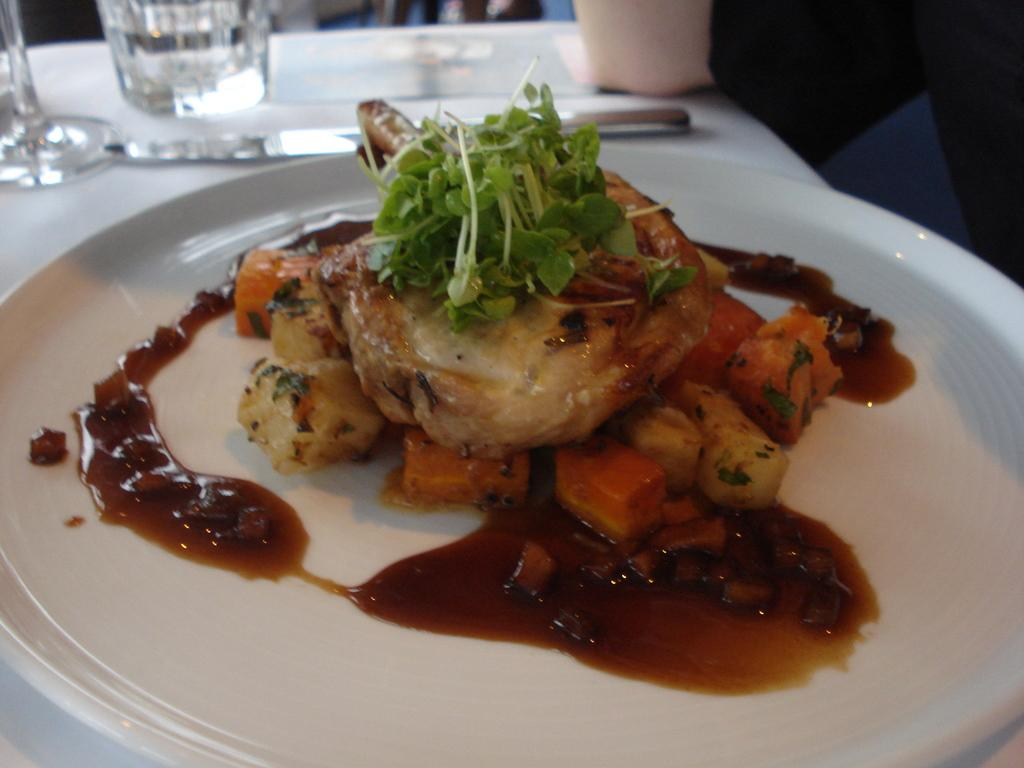What is present on the plate in the image? There are food items in a plate in the image. What can be seen in the background of the image? There are glasses and other objects on a white color table in the background of the image. How is the background of the image depicted? The background of the image is blurred. How many mice are running around on the table in the image? There are no mice present in the image; it only shows food items, glasses, and other objects on a white table. 